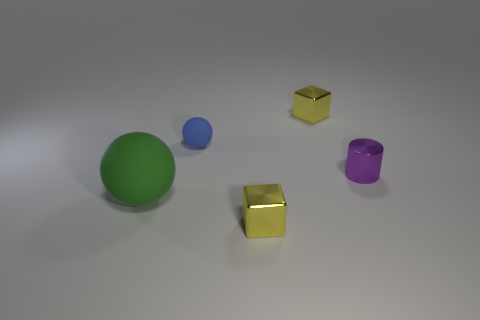Which object in the image is the largest? The green ball seems to be the largest object in the image. 